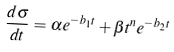Convert formula to latex. <formula><loc_0><loc_0><loc_500><loc_500>\frac { d \sigma } { d t } = \alpha e ^ { - b _ { 1 } t } + \beta t ^ { n } e ^ { - b _ { 2 } t }</formula> 